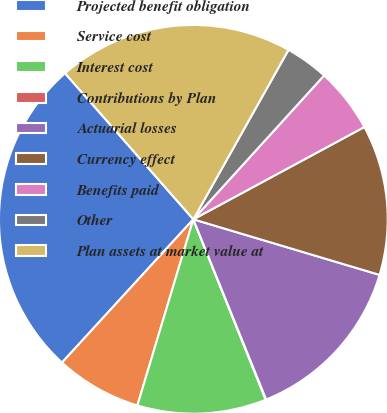Convert chart. <chart><loc_0><loc_0><loc_500><loc_500><pie_chart><fcel>Projected benefit obligation<fcel>Service cost<fcel>Interest cost<fcel>Contributions by Plan<fcel>Actuarial losses<fcel>Currency effect<fcel>Benefits paid<fcel>Other<fcel>Plan assets at market value at<nl><fcel>26.72%<fcel>7.16%<fcel>10.72%<fcel>0.04%<fcel>14.27%<fcel>12.49%<fcel>5.38%<fcel>3.6%<fcel>19.61%<nl></chart> 